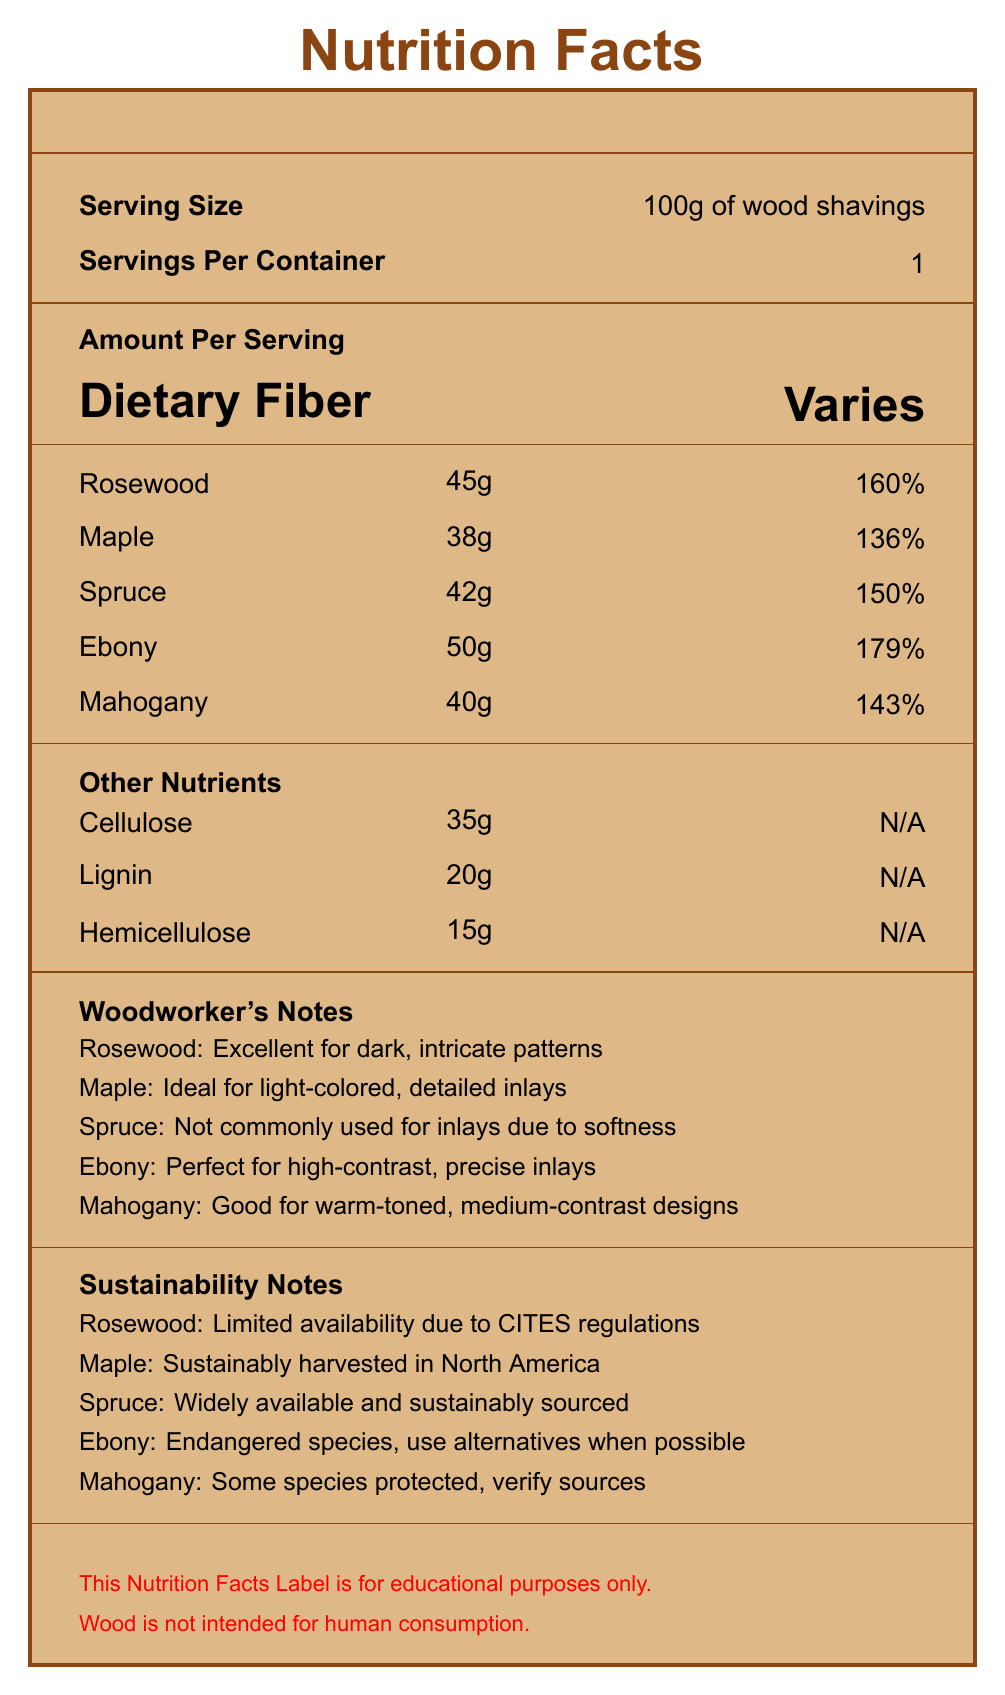what is the serving size? The serving size is specified at the beginning of the document: "Serving Size: 100g of wood shavings".
Answer: 100g of wood shavings which wood has the highest dietary fiber content? The document mentions that Ebony has 50g of dietary fiber, which is the highest among all the listed woods.
Answer: Ebony how much daily value percentage does spruce provide? For spruce, the dietary fiber amount is given as 42g, and the daily value percentage is 150%.
Answer: 150% name two woods that provide more than 140% of the daily value of dietary fiber Rosewood provides 160%, and Mahogany provides 143% daily value of dietary fiber according to the document.
Answer: Rosewood and Mahogany what is the amount of hemicellulose in the sample? The document lists hemicellulose in the "Other Nutrients" section with an amount of 15g.
Answer: 15g how many grams of lignin are there per serving? The amount of lignin per serving is specified as 20g in the "Other Nutrients" section.
Answer: 20g which two woods are suitable for creating high-contrast, precise inlays? The woodworker's notes mention that Ebony is perfect for high-contrast, precise inlays and Rosewood is excellent for dark, intricate patterns, which can include high-contrast.
Answer: Ebony and Rosewood which wood is suggested as ideal for light-colored, detailed inlays? 
A. Rosewood
B. Maple
C. Spruce
D. Ebony The woodworker's notes specify that Maple is ideal for light-colored, detailed inlays.
Answer: B. Maple of the following woods, which one offers the least amount of dietary fiber?
i. Spruce
ii. Ebony
iii. Maple
iv. Mahogany Maple offers 38g of dietary fiber, which is the least among the options listed.
Answer: iii. Maple is wood intended for human consumption? The disclaimer at the end of the document specifically states that "Wood is not intended for human consumption."
Answer: No is the availability of rosewood limited? The sustainability notes mention that Rosewood has limited availability due to CITES regulations.
Answer: Yes summarize the key points of the entire document. The explanation emphasizes the structure and key information provided in the Nutrition Facts Label, including nutritional content, usability in woodworking, and sustainability considerations.
Answer: The document is a Nutrition Facts Label for 100g servings of wood shavings from different wood species used in guitar making. It provides dietary fiber content for Rosewood, Maple, Spruce, Ebony, and Mahogany, as well as other nutrients like cellulose, lignin, and hemicellulose. The document includes woodworker notes on the suitability for inlays and sustainability notes for each wood type. There is a disclaimer that wood is not for human consumption. what is the exact daily value of dietary fiber for each wood mentioned? The document provides the daily value percentage but not the exact daily requirement for dietary fiber, so calculating the precise daily value is not possible solely based on the presented information.
Answer: Not enough information 